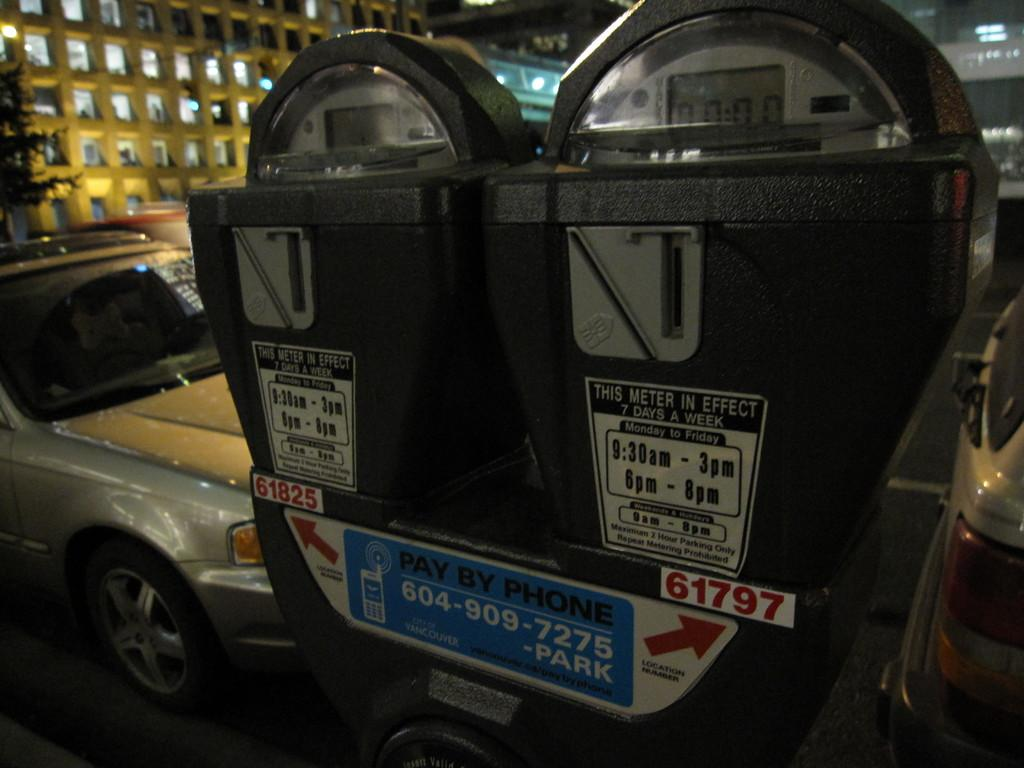<image>
Summarize the visual content of the image. A parking meter with one of the numbers being 61797 on the right side. 